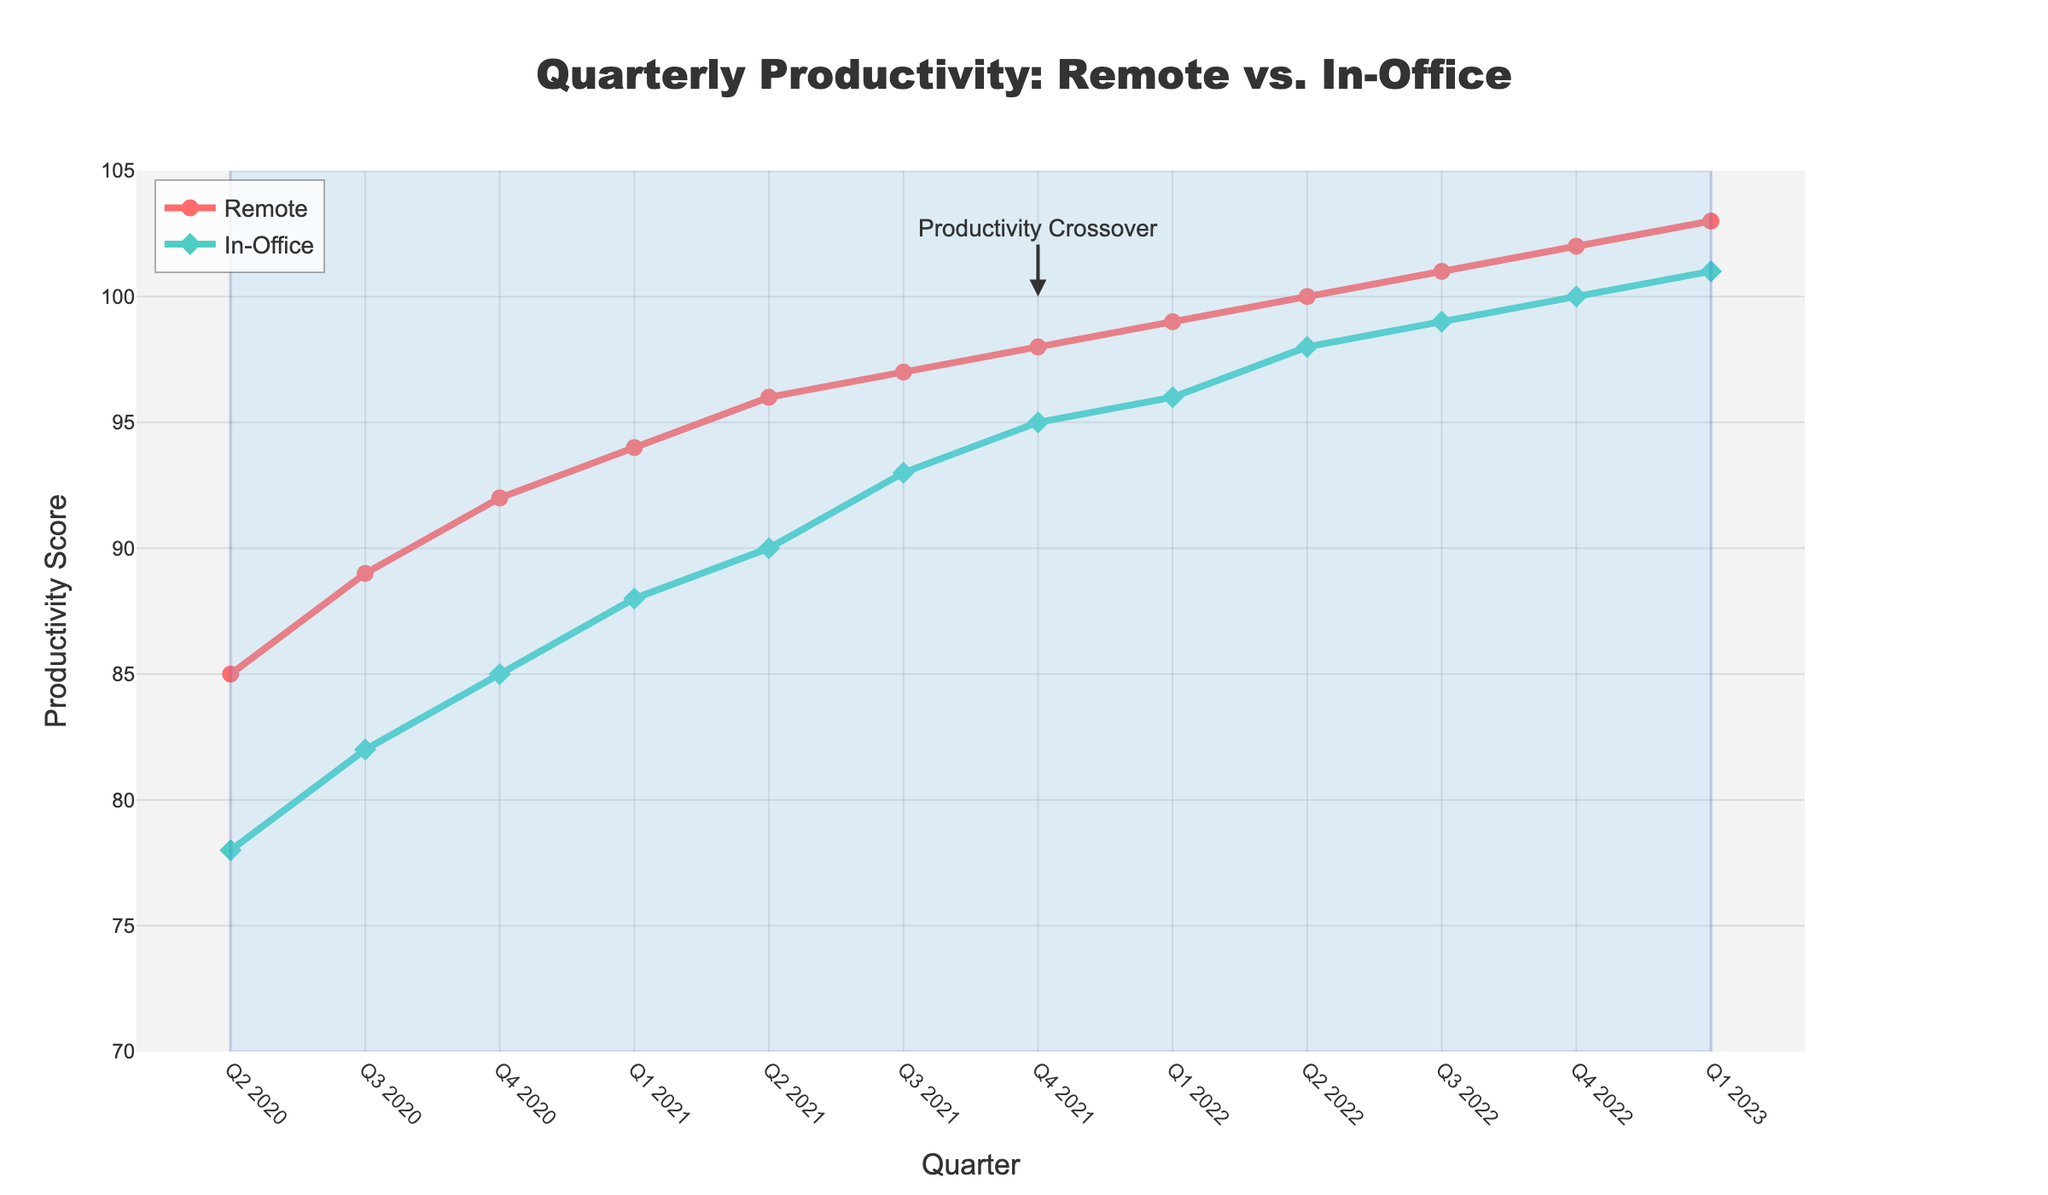What quarter did remote productivity first surpass in-office productivity? The annotation on the figure, "Productivity Crossover," points to Q4 2021 as the quarter when remote productivity first surpassed in-office productivity.
Answer: Q4 2021 What is the overall trend observed in both remote and in-office productivity since Q2 2020? Both remote and in-office productivity show a general upward trend. Remote productivity starts at 85 and reaches 103 by Q1 2023, while in-office productivity starts at 78 and reaches 101 over the same period.
Answer: Upward Which quarter had the highest productivity score for remote workers? By examining the graph, we see that the highest productivity score for remote workers occurs in Q1 2023, reaching 103.
Answer: Q1 2023 How much did in-office productivity increase from Q2 2020 to Q1 2023? In-office productivity increased from 78 in Q2 2020 to 101 in Q1 2023. The difference is calculated as 101 - 78 = 23.
Answer: 23 Among all the quarters, which one showed the smallest gap between remote and in-office productivity? The smallest gap between the productivity scores occurs in Q1 2023, where the difference is 103 (Remote) - 101 (In-Office) = 2.
Answer: Q1 2023 Which line, remote or in-office, has markers shaped like diamonds? The in-office productivity line features markers shaped like diamonds, as shown by the green line on the figure.
Answer: In-Office Calculate the average remote productivity score from Q2 2020 to Q1 2021. The remote productivity scores for these quarters are 85, 89, 92, and 94. The average is calculated as (85 + 89 + 92 + 94) / 4 = 90.
Answer: 90 Is the rate of increase in remote productivity greater than in-office productivity after Q4 2021 until Q1 2023? From Q4 2021 to Q1 2023, remote productivity increases from 98 to 103 (a change of 5), and in-office productivity rises from 95 to 101 (a change of 6). The rate of increase can be compared as remote increases by about 5.10% (5/98), while in-office increases by about 6.32% (6/95). Therefore, the rate of increase for in-office productivity is greater.
Answer: No 